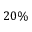Convert formula to latex. <formula><loc_0><loc_0><loc_500><loc_500>2 0 \%</formula> 